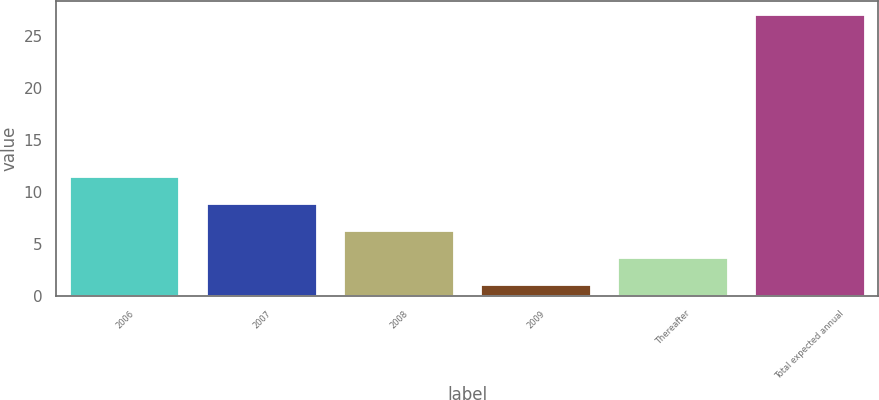<chart> <loc_0><loc_0><loc_500><loc_500><bar_chart><fcel>2006<fcel>2007<fcel>2008<fcel>2009<fcel>Thereafter<fcel>Total expected annual<nl><fcel>11.4<fcel>8.8<fcel>6.2<fcel>1<fcel>3.6<fcel>27<nl></chart> 